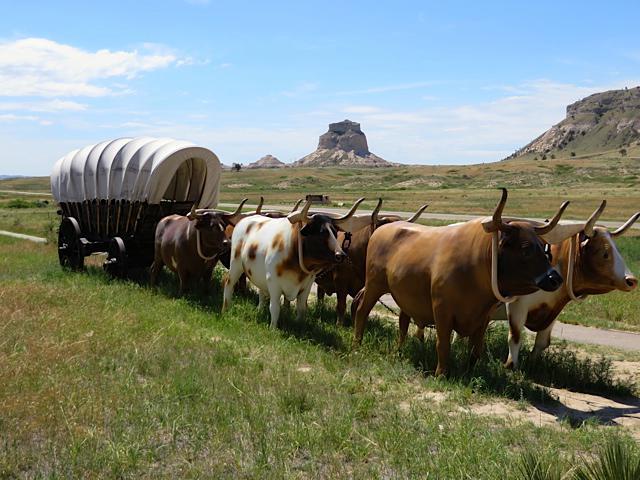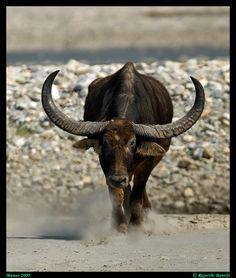The first image is the image on the left, the second image is the image on the right. For the images displayed, is the sentence "An image shows all brown oxen hitched to a green covered wagon with red wheels and aimed rightward." factually correct? Answer yes or no. No. The first image is the image on the left, the second image is the image on the right. Considering the images on both sides, is "In the image to the left we've got two work-animals." valid? Answer yes or no. No. 